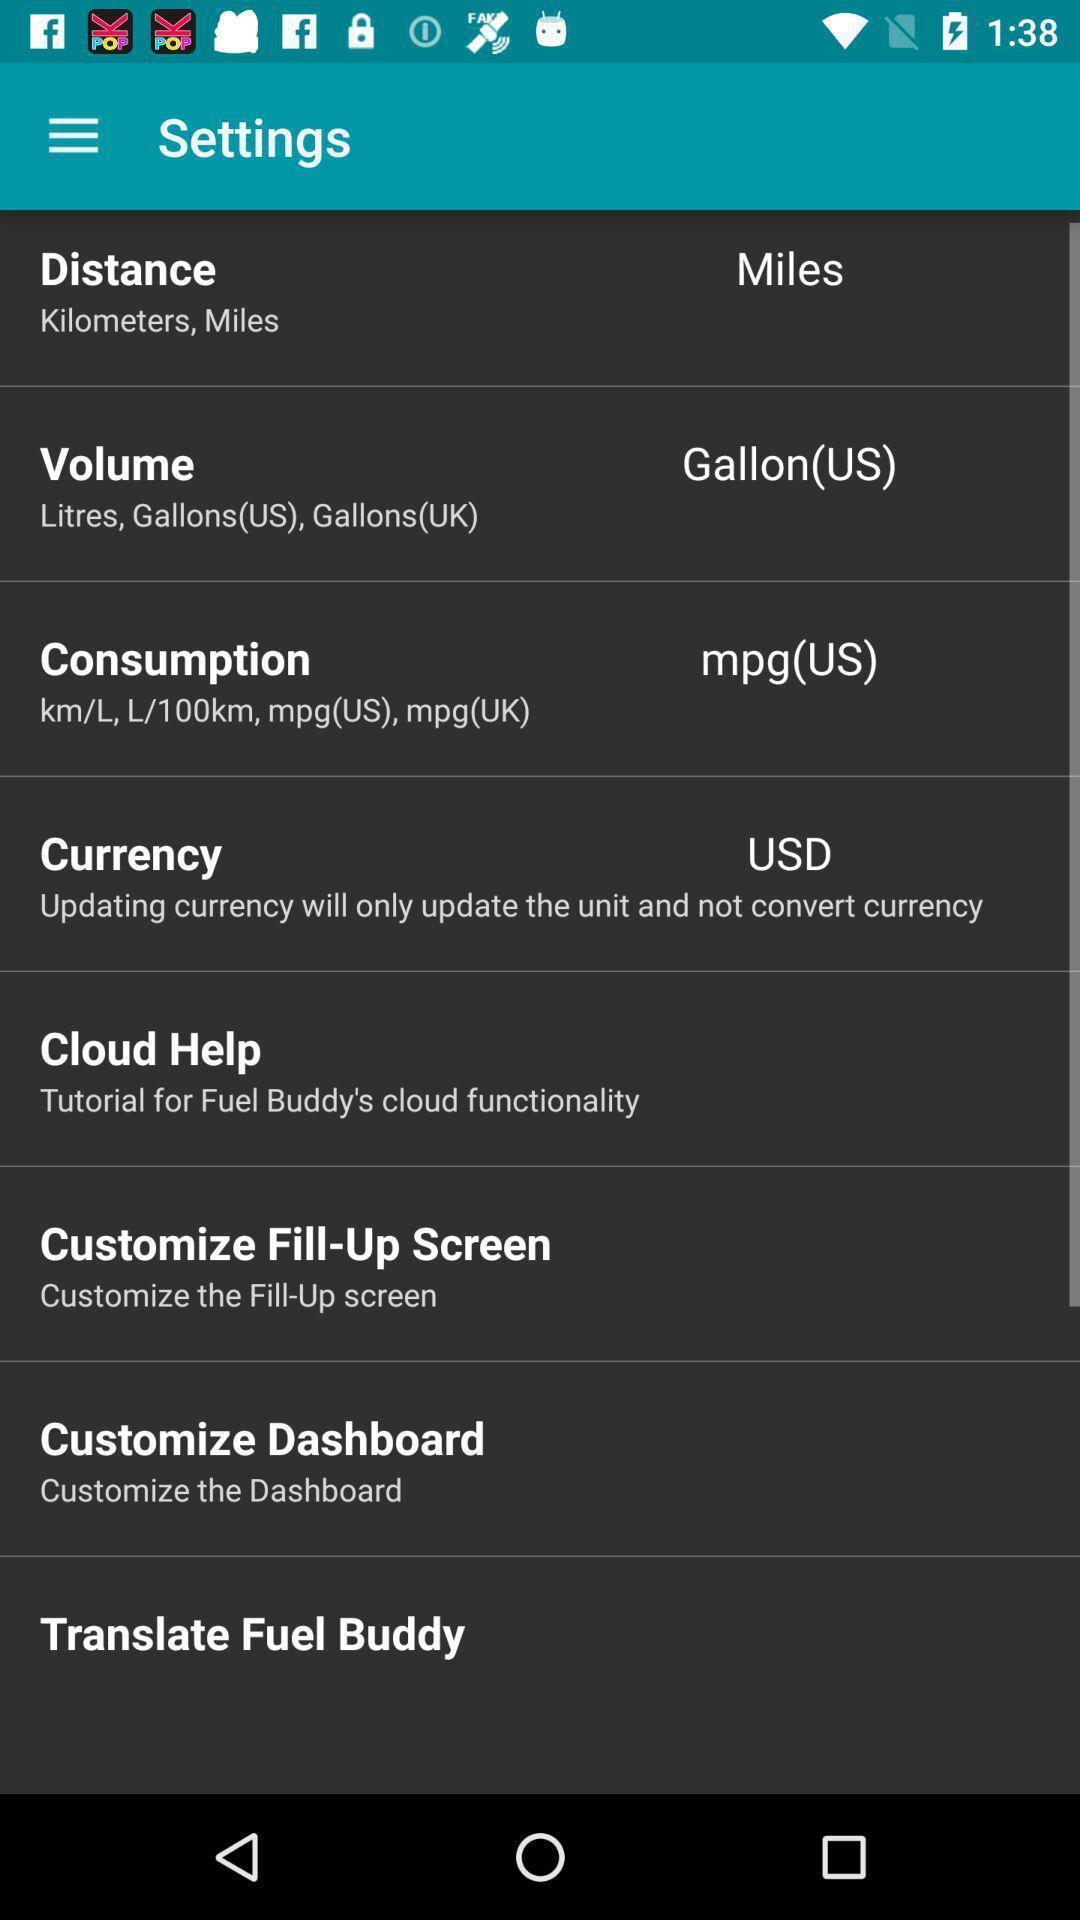Give me a summary of this screen capture. Settings page with listed customization options. 